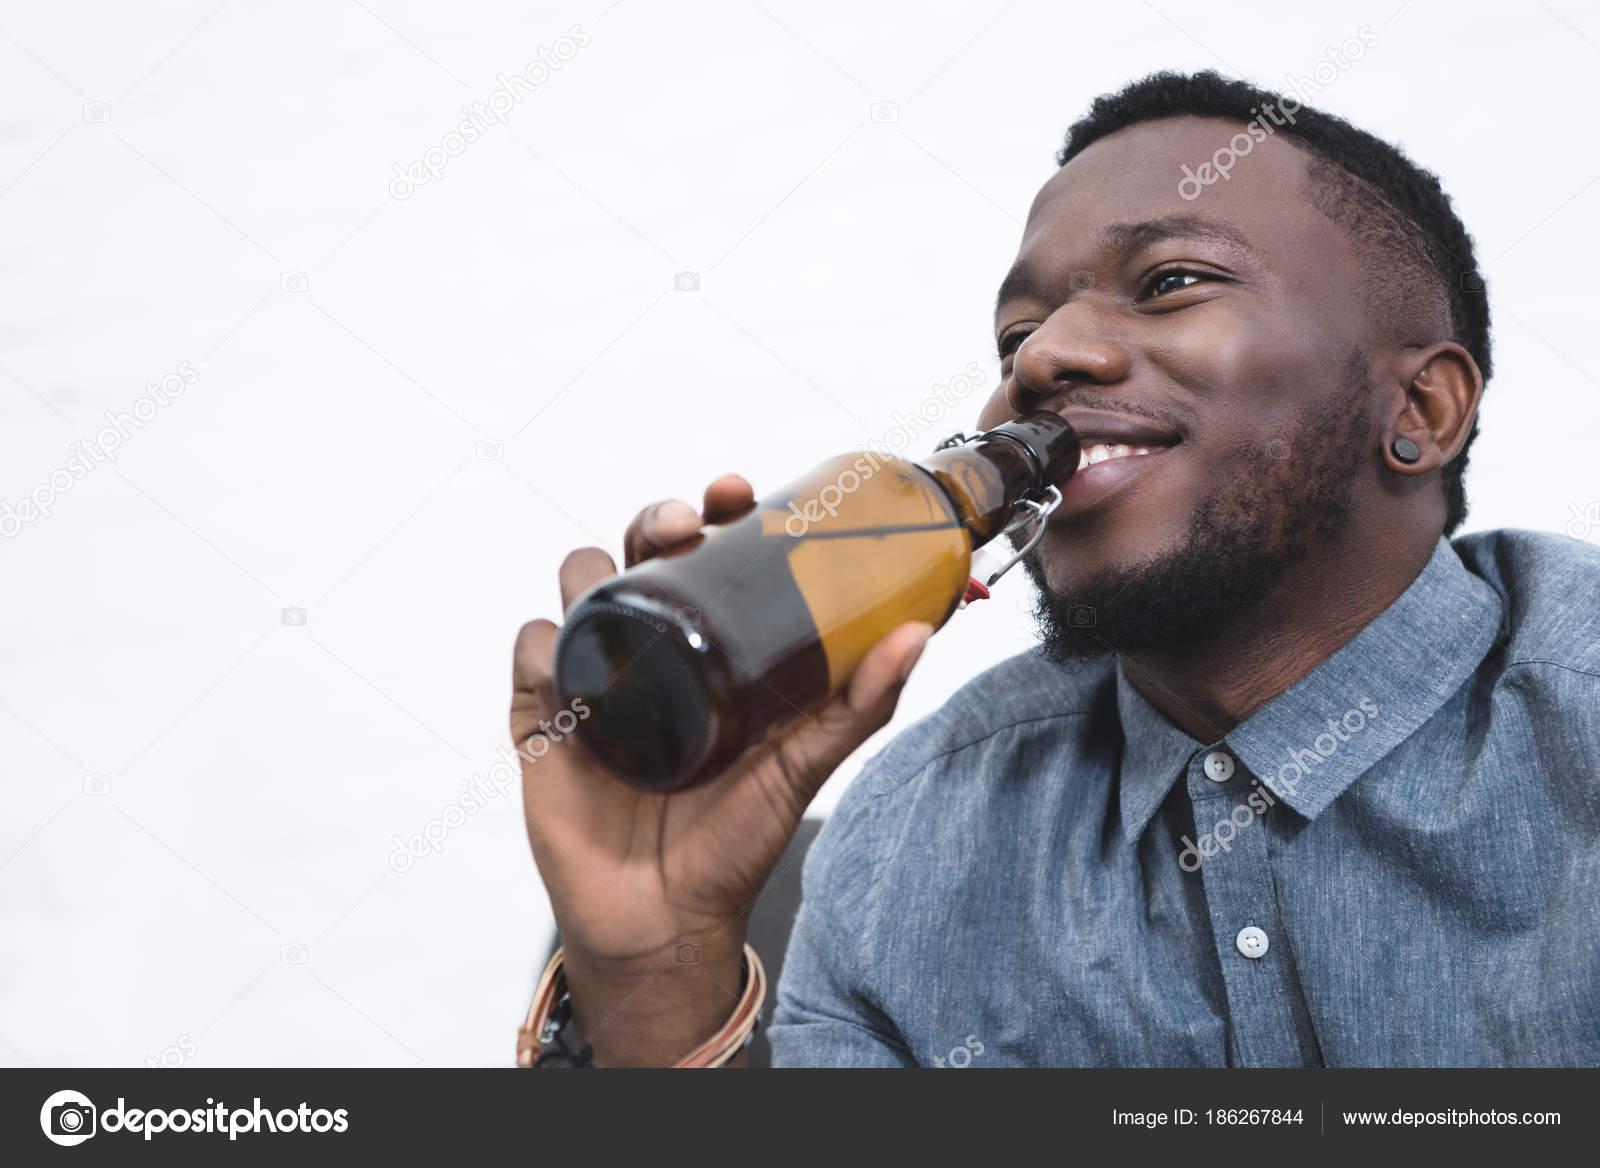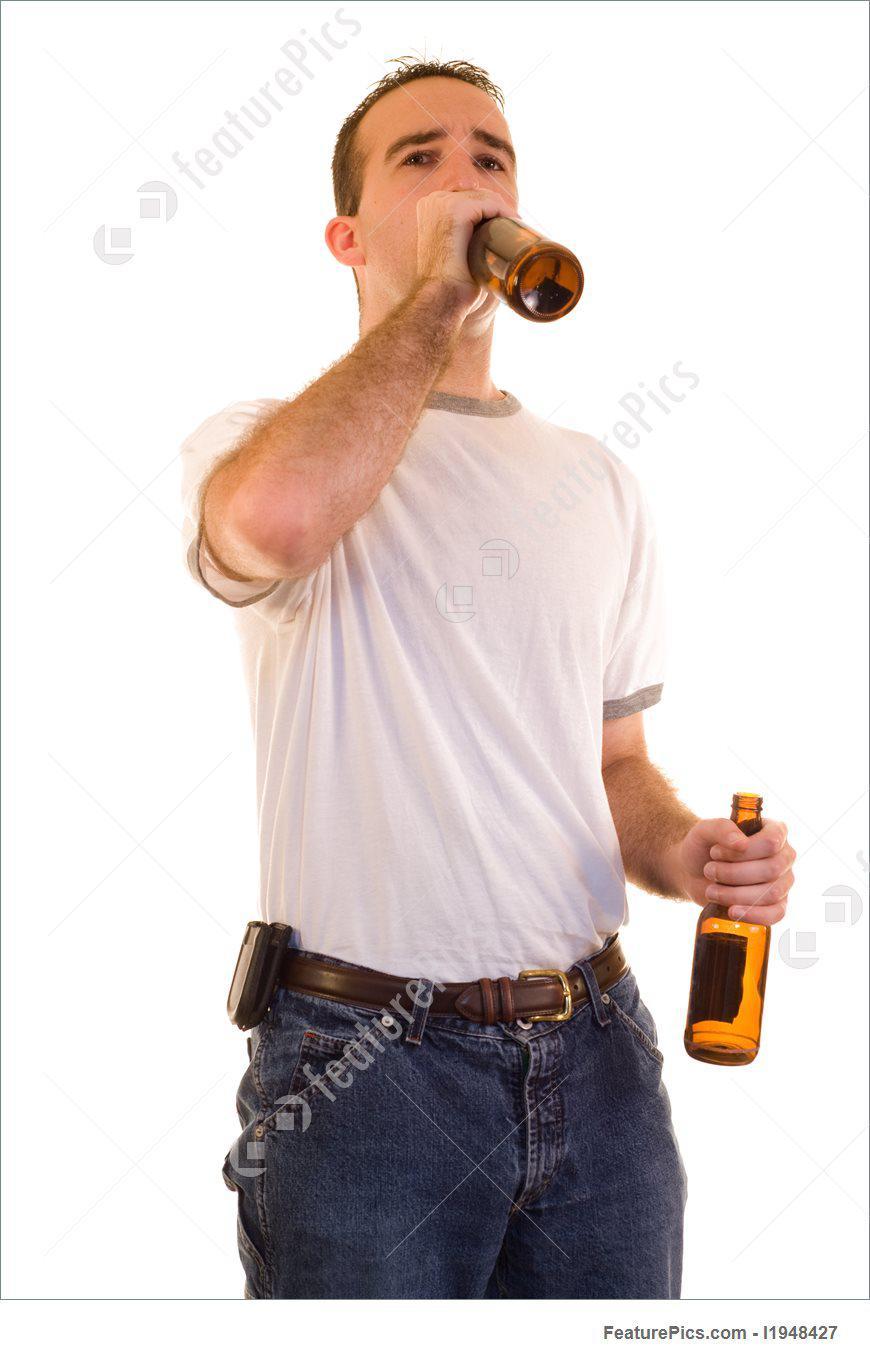The first image is the image on the left, the second image is the image on the right. For the images shown, is this caption "The man in the image on the left is holding a green bottle." true? Answer yes or no. No. The first image is the image on the left, the second image is the image on the right. Analyze the images presented: Is the assertion "There is a total of three bottles or cans of beer." valid? Answer yes or no. Yes. 